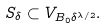<formula> <loc_0><loc_0><loc_500><loc_500>S _ { \delta } \subset V _ { B _ { 0 } \delta ^ { \lambda / 2 } } .</formula> 